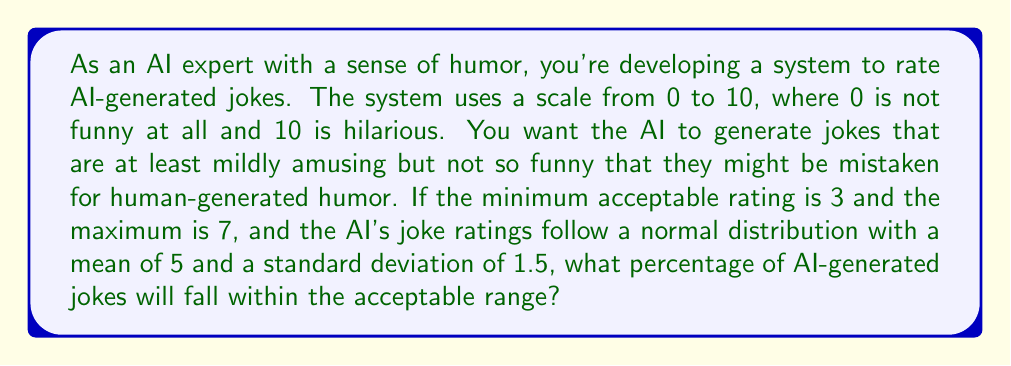What is the answer to this math problem? Let's approach this step-by-step:

1) We're dealing with a normal distribution with mean $\mu = 5$ and standard deviation $\sigma = 1.5$.

2) We need to find the probability that a joke's rating $X$ falls between 3 and 7, i.e., $P(3 \leq X \leq 7)$.

3) To use the standard normal distribution, we need to standardize these values:

   For the lower bound: $z_1 = \frac{3 - 5}{1.5} = -\frac{4}{3} \approx -1.33$
   For the upper bound: $z_2 = \frac{7 - 5}{1.5} = \frac{4}{3} \approx 1.33$

4) Now we need to find $P(-1.33 \leq Z \leq 1.33)$, where $Z$ is the standard normal variable.

5) This probability is equal to $\Phi(1.33) - \Phi(-1.33)$, where $\Phi$ is the cumulative distribution function of the standard normal distribution.

6) Using a standard normal table or calculator:
   $\Phi(1.33) \approx 0.9082$
   $\Phi(-1.33) = 1 - \Phi(1.33) \approx 0.0918$

7) Therefore, $P(-1.33 \leq Z \leq 1.33) = 0.9082 - 0.0918 = 0.8164$

8) Convert to percentage: $0.8164 * 100\% = 81.64\%$
Answer: $81.64\%$ 